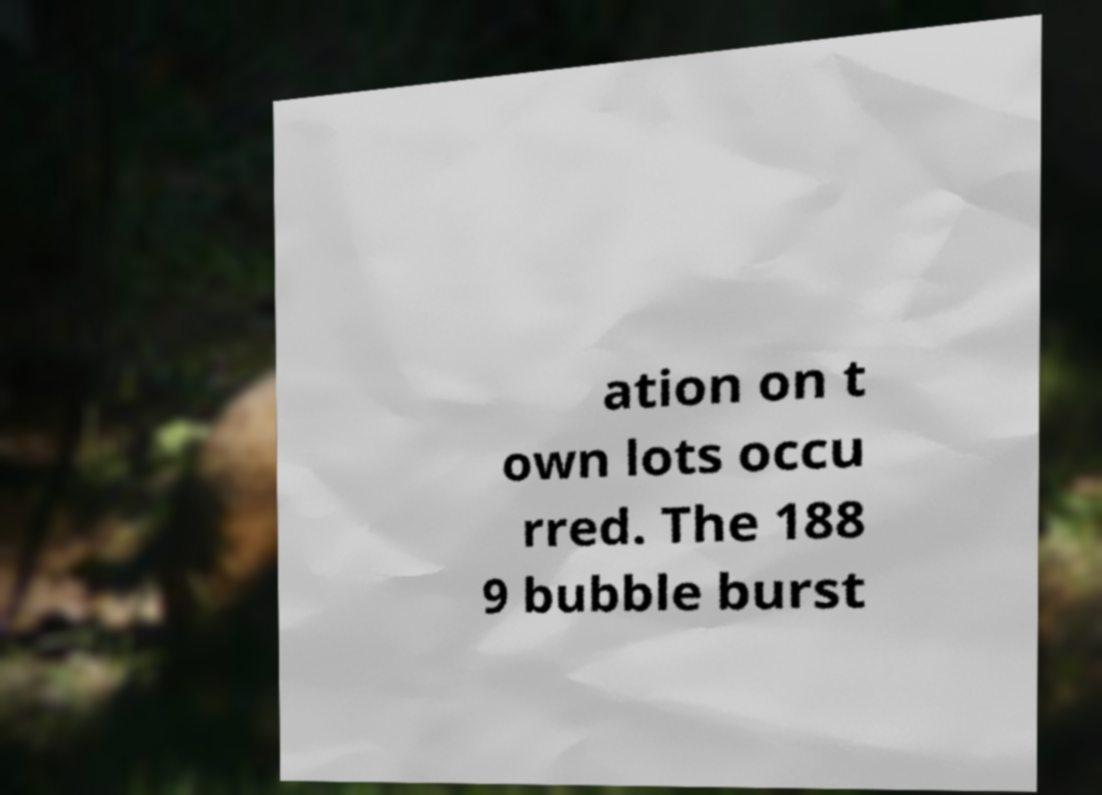For documentation purposes, I need the text within this image transcribed. Could you provide that? ation on t own lots occu rred. The 188 9 bubble burst 